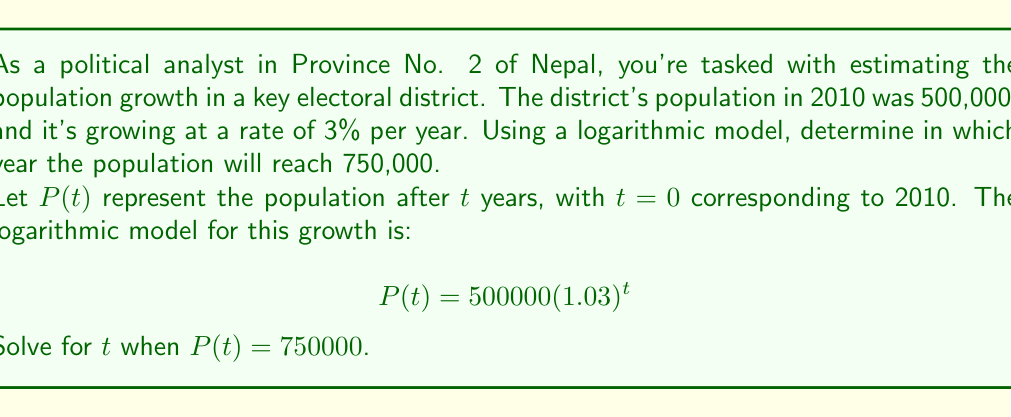Show me your answer to this math problem. To solve this problem, we'll use the logarithmic properties to isolate $t$:

1) Start with the equation:
   $$750000 = 500000(1.03)^t$$

2) Divide both sides by 500000:
   $$1.5 = (1.03)^t$$

3) Take the natural logarithm of both sides:
   $$\ln(1.5) = \ln((1.03)^t)$$

4) Use the logarithm property $\ln(a^b) = b\ln(a)$:
   $$\ln(1.5) = t\ln(1.03)$$

5) Solve for $t$ by dividing both sides by $\ln(1.03)$:
   $$t = \frac{\ln(1.5)}{\ln(1.03)}$$

6) Calculate the value of $t$:
   $$t \approx 13.86$$

7) Since $t$ represents the number of years after 2010, we need to add this to 2010 and round up to the nearest year:
   $2010 + 13.86 \approx 2023.86$

Therefore, the population will reach 750,000 in 2024.
Answer: The population of the electoral district will reach 750,000 in 2024. 